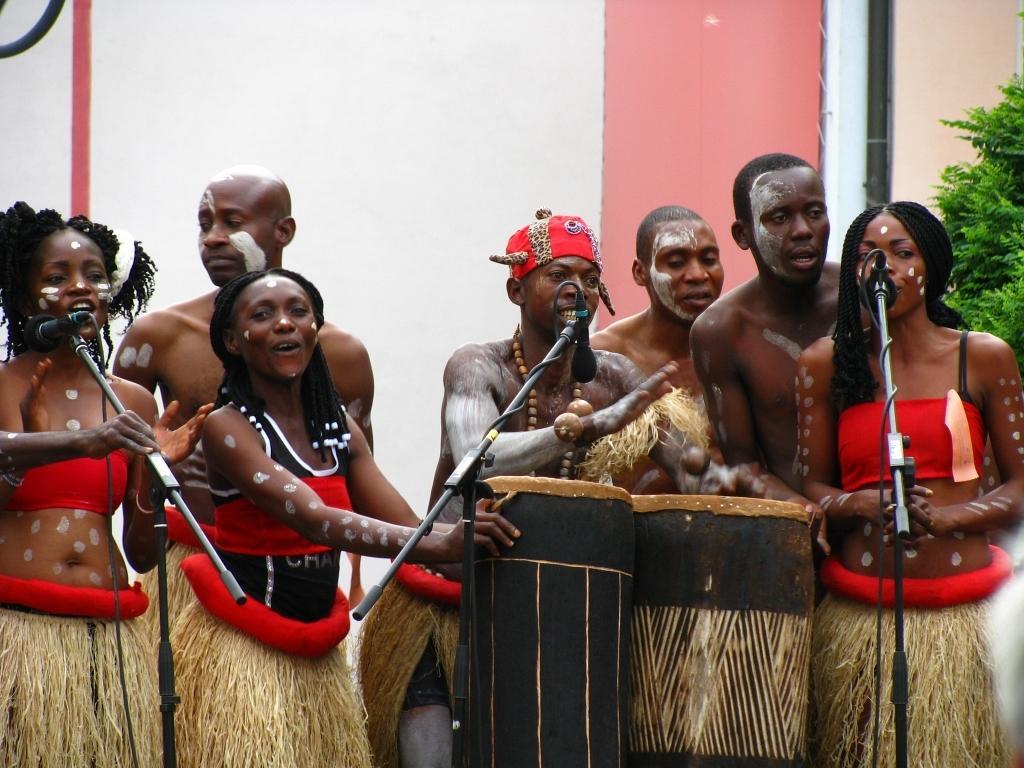Describe this image in one or two sentences. In this image i can see a group of persons performing a act and in front of them there are the drums kept and there are the mikes kept in front of them ,back side of them there is a wall ,on right side there is a planet visible. 